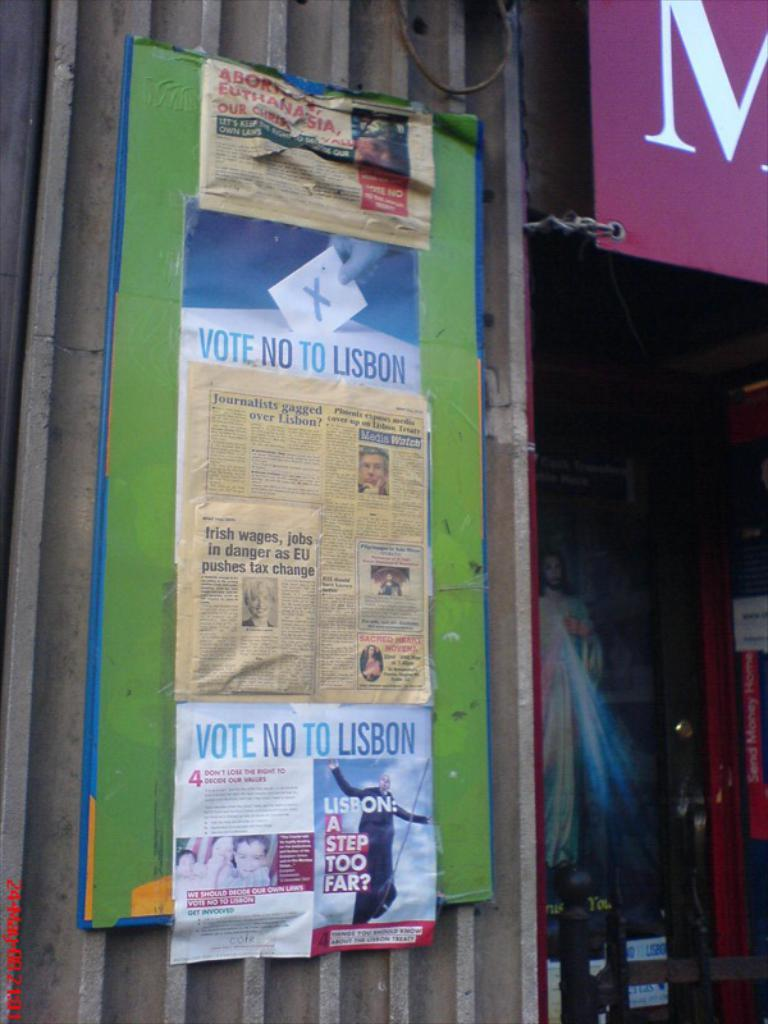<image>
Create a compact narrative representing the image presented. A board with newspapers and posters asking people to vote no to Lisbon stuck to it 